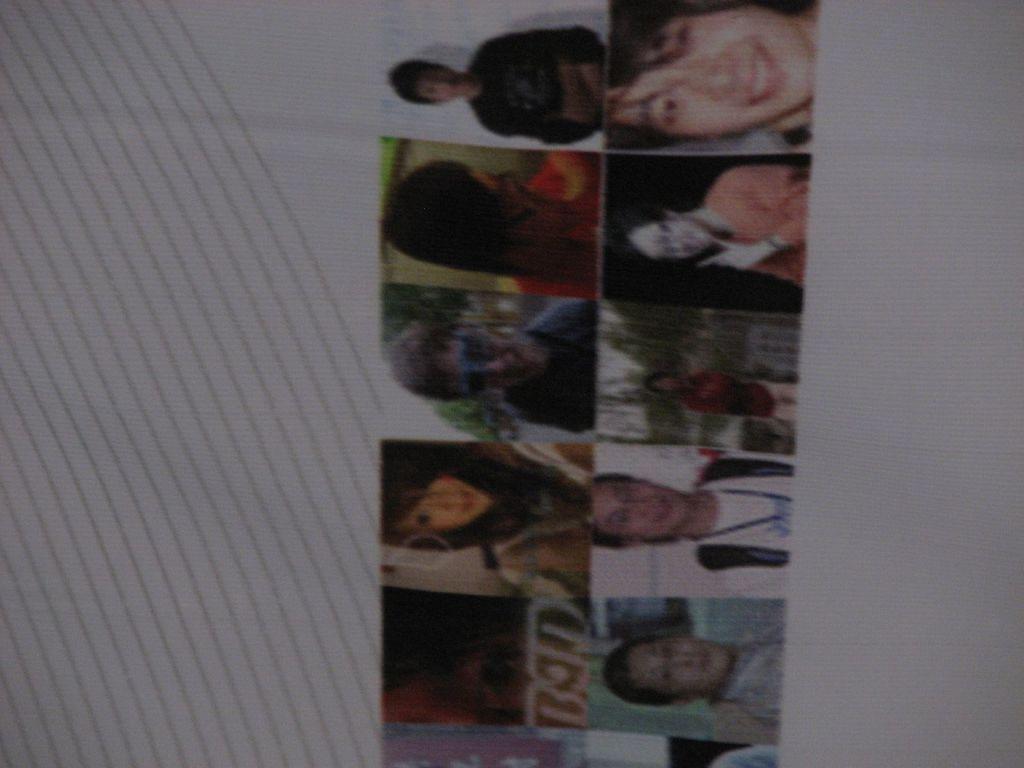In one or two sentences, can you explain what this image depicts? In this picture we can see photos of different people on a white surface. 